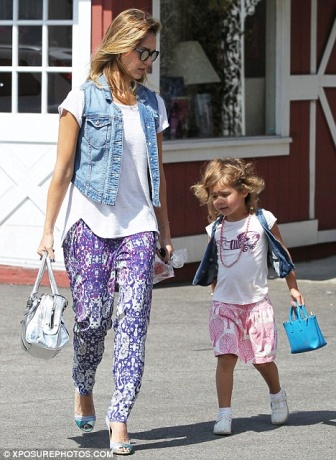Describe the following image. In the image, a mother and daughter are sharing a moment together on a sunny day. The mother, stylishly dressed in a denim vest over a white shirt and vibrant purple and white patterned pants, walks confidently ahead. She holds a white purse in one hand and a blue bag in the other, suggesting a recent shopping trip. Her sunglasses add a touch of cool to her ensemble.

Behind her is her daughter, a young girl clad in an adorable pink and white dress and white sneakers, echoing her mother's fashion sense with a miniature blue purse slung over her shoulder. The bonding between them is palpable, exemplified by their synchronized steps.

They stroll past a charming building with a red facade and white-trimmed windows, capturing the simplicity and beauty of everyday moments. The clear sidewalk emphasizes their solitary walk, making the scene all the more intimate and heartwarming. 